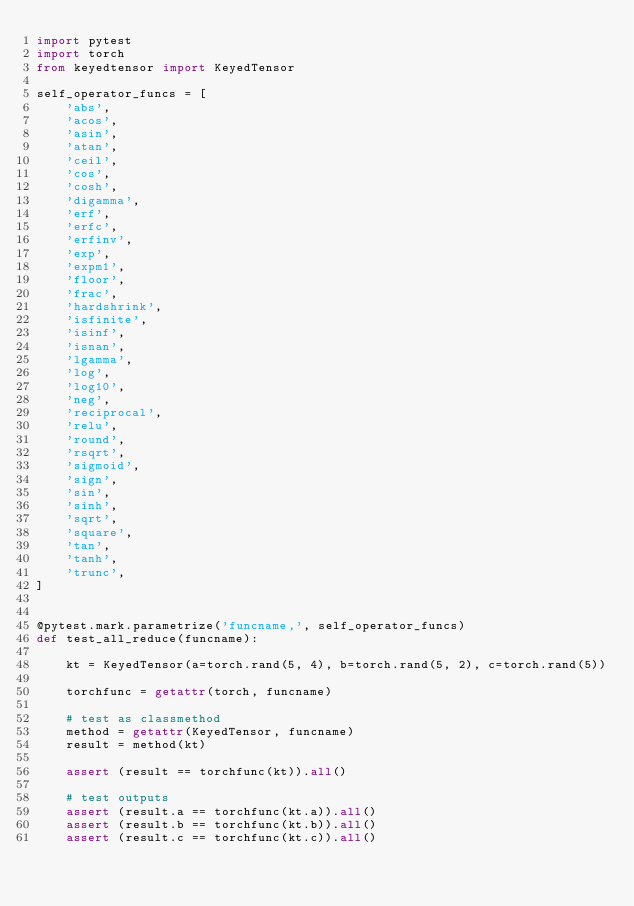Convert code to text. <code><loc_0><loc_0><loc_500><loc_500><_Python_>import pytest
import torch
from keyedtensor import KeyedTensor

self_operator_funcs = [
    'abs',
    'acos',
    'asin',
    'atan',
    'ceil',
    'cos',
    'cosh',
    'digamma',
    'erf',
    'erfc',
    'erfinv',
    'exp',
    'expm1',
    'floor',
    'frac',
    'hardshrink',
    'isfinite',
    'isinf',
    'isnan',
    'lgamma',
    'log',
    'log10',
    'neg',
    'reciprocal',
    'relu',
    'round',
    'rsqrt',
    'sigmoid',
    'sign',
    'sin',
    'sinh',
    'sqrt',
    'square',
    'tan',
    'tanh',
    'trunc',
]


@pytest.mark.parametrize('funcname,', self_operator_funcs)
def test_all_reduce(funcname):

    kt = KeyedTensor(a=torch.rand(5, 4), b=torch.rand(5, 2), c=torch.rand(5))

    torchfunc = getattr(torch, funcname)

    # test as classmethod
    method = getattr(KeyedTensor, funcname)
    result = method(kt)

    assert (result == torchfunc(kt)).all()

    # test outputs
    assert (result.a == torchfunc(kt.a)).all()
    assert (result.b == torchfunc(kt.b)).all()
    assert (result.c == torchfunc(kt.c)).all()
</code> 